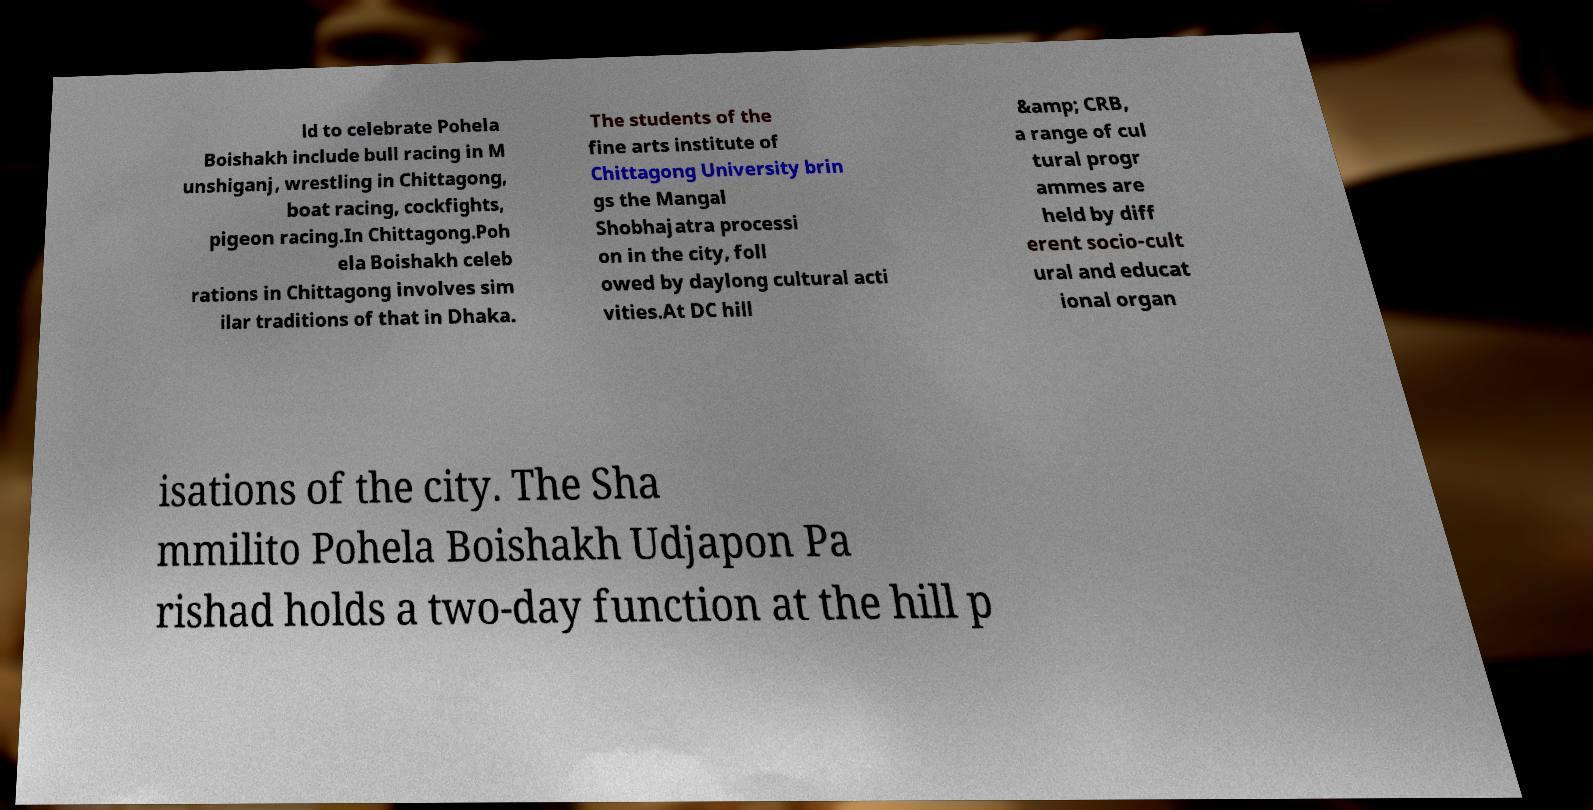There's text embedded in this image that I need extracted. Can you transcribe it verbatim? ld to celebrate Pohela Boishakh include bull racing in M unshiganj, wrestling in Chittagong, boat racing, cockfights, pigeon racing.In Chittagong.Poh ela Boishakh celeb rations in Chittagong involves sim ilar traditions of that in Dhaka. The students of the fine arts institute of Chittagong University brin gs the Mangal Shobhajatra processi on in the city, foll owed by daylong cultural acti vities.At DC hill &amp; CRB, a range of cul tural progr ammes are held by diff erent socio-cult ural and educat ional organ isations of the city. The Sha mmilito Pohela Boishakh Udjapon Pa rishad holds a two-day function at the hill p 